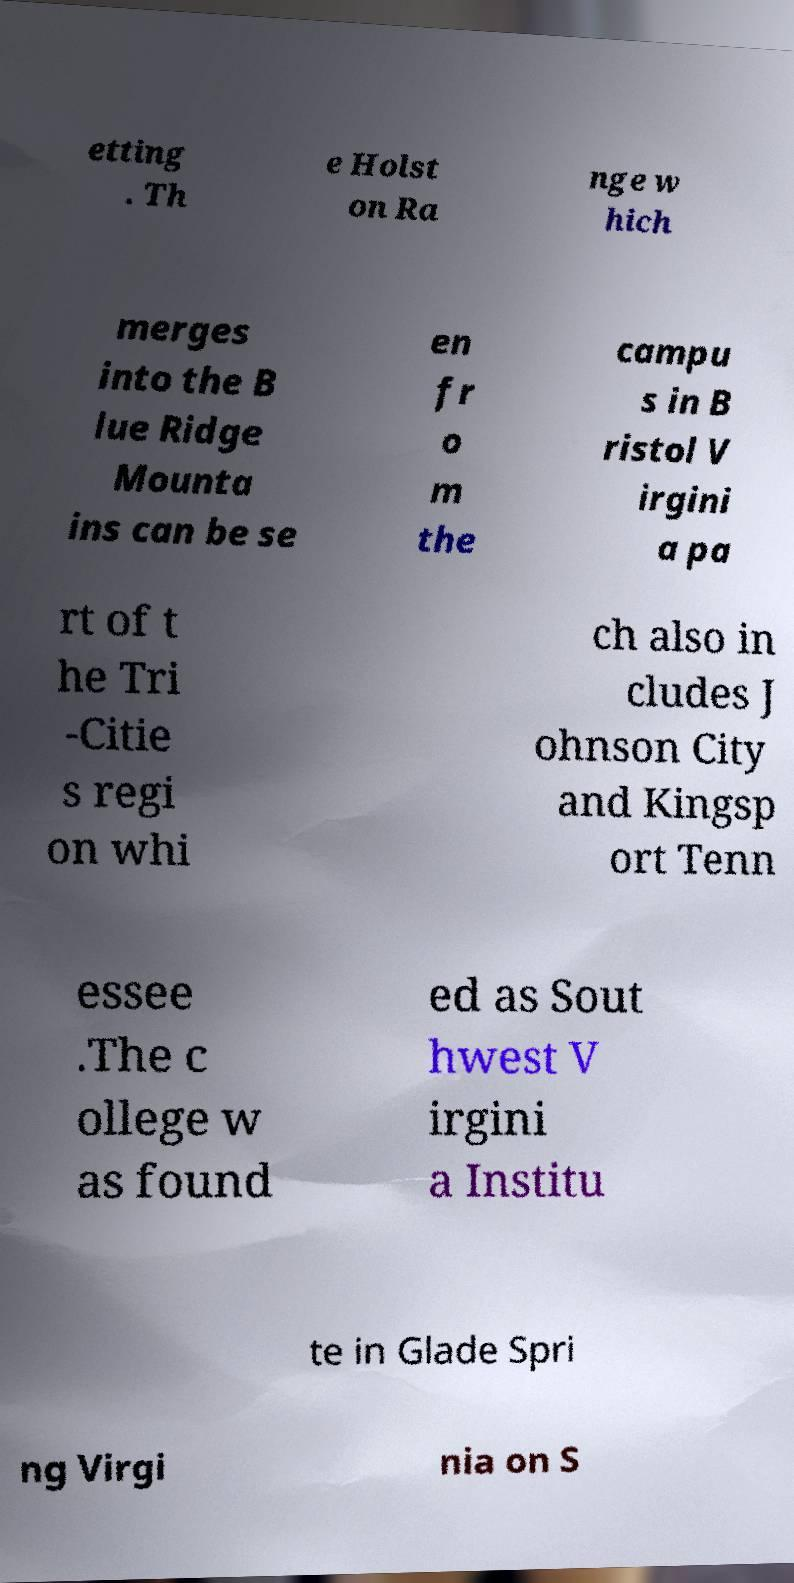Can you accurately transcribe the text from the provided image for me? etting . Th e Holst on Ra nge w hich merges into the B lue Ridge Mounta ins can be se en fr o m the campu s in B ristol V irgini a pa rt of t he Tri -Citie s regi on whi ch also in cludes J ohnson City and Kingsp ort Tenn essee .The c ollege w as found ed as Sout hwest V irgini a Institu te in Glade Spri ng Virgi nia on S 